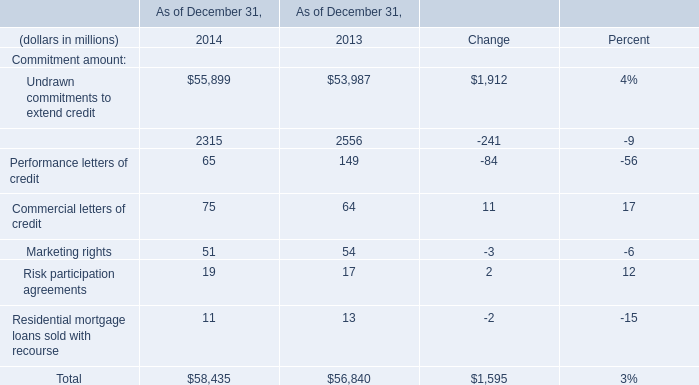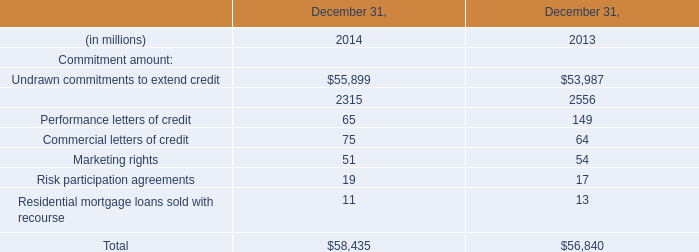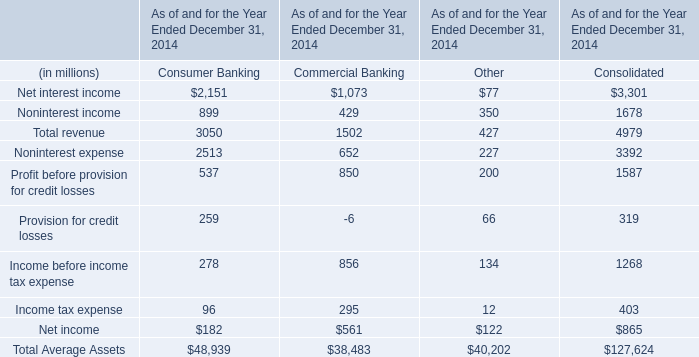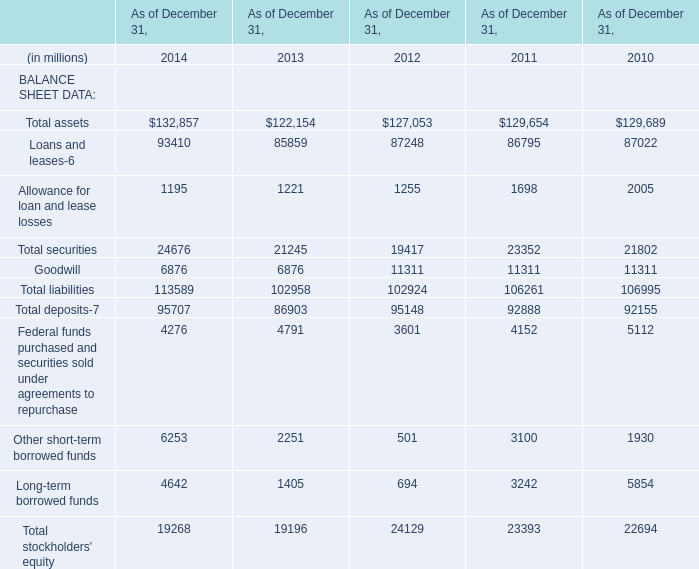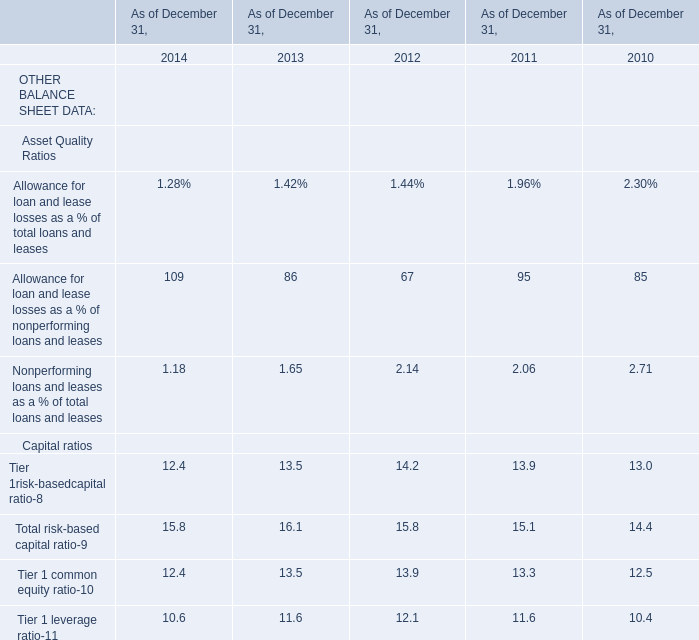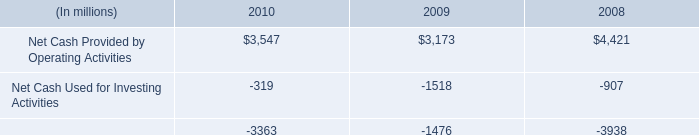What is the difference between the greatest Capital ratios in 2014 and 2013？ 
Computations: (15.8 - 16.1)
Answer: -0.3. 